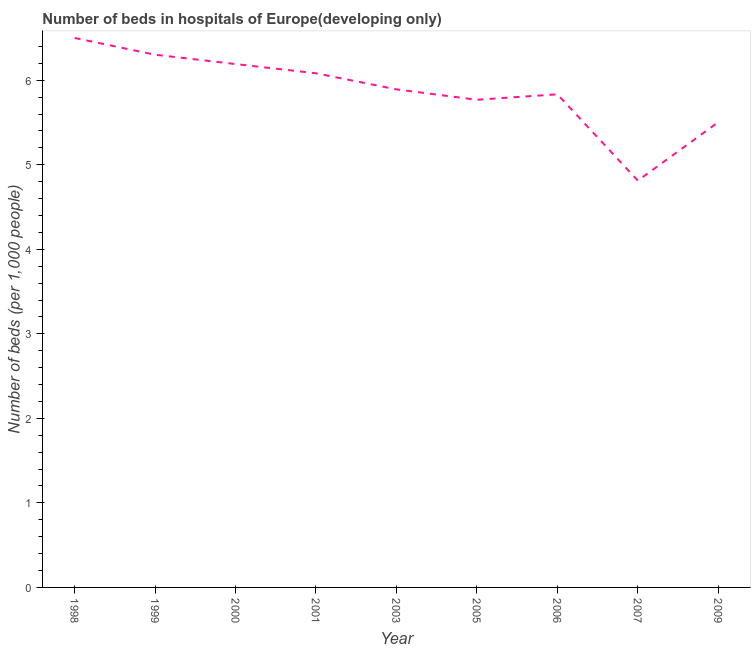What is the number of hospital beds in 1999?
Offer a very short reply. 6.3. Across all years, what is the maximum number of hospital beds?
Your answer should be compact. 6.5. Across all years, what is the minimum number of hospital beds?
Give a very brief answer. 4.81. In which year was the number of hospital beds maximum?
Keep it short and to the point. 1998. In which year was the number of hospital beds minimum?
Your answer should be compact. 2007. What is the sum of the number of hospital beds?
Your answer should be compact. 52.89. What is the difference between the number of hospital beds in 1998 and 2009?
Your response must be concise. 1. What is the average number of hospital beds per year?
Provide a succinct answer. 5.88. What is the median number of hospital beds?
Offer a very short reply. 5.89. What is the ratio of the number of hospital beds in 1998 to that in 1999?
Provide a short and direct response. 1.03. Is the difference between the number of hospital beds in 1998 and 1999 greater than the difference between any two years?
Give a very brief answer. No. What is the difference between the highest and the second highest number of hospital beds?
Provide a short and direct response. 0.2. Is the sum of the number of hospital beds in 1999 and 2000 greater than the maximum number of hospital beds across all years?
Keep it short and to the point. Yes. What is the difference between the highest and the lowest number of hospital beds?
Offer a very short reply. 1.69. In how many years, is the number of hospital beds greater than the average number of hospital beds taken over all years?
Your response must be concise. 5. How many lines are there?
Your response must be concise. 1. What is the difference between two consecutive major ticks on the Y-axis?
Provide a short and direct response. 1. Are the values on the major ticks of Y-axis written in scientific E-notation?
Offer a very short reply. No. Does the graph contain grids?
Ensure brevity in your answer.  No. What is the title of the graph?
Provide a succinct answer. Number of beds in hospitals of Europe(developing only). What is the label or title of the Y-axis?
Keep it short and to the point. Number of beds (per 1,0 people). What is the Number of beds (per 1,000 people) in 1998?
Your answer should be compact. 6.5. What is the Number of beds (per 1,000 people) in 1999?
Give a very brief answer. 6.3. What is the Number of beds (per 1,000 people) of 2000?
Provide a succinct answer. 6.19. What is the Number of beds (per 1,000 people) of 2001?
Offer a very short reply. 6.08. What is the Number of beds (per 1,000 people) in 2003?
Your answer should be compact. 5.89. What is the Number of beds (per 1,000 people) of 2005?
Your answer should be compact. 5.77. What is the Number of beds (per 1,000 people) of 2006?
Provide a succinct answer. 5.83. What is the Number of beds (per 1,000 people) of 2007?
Give a very brief answer. 4.81. What is the Number of beds (per 1,000 people) in 2009?
Make the answer very short. 5.51. What is the difference between the Number of beds (per 1,000 people) in 1998 and 1999?
Offer a terse response. 0.2. What is the difference between the Number of beds (per 1,000 people) in 1998 and 2000?
Offer a terse response. 0.31. What is the difference between the Number of beds (per 1,000 people) in 1998 and 2001?
Your answer should be very brief. 0.42. What is the difference between the Number of beds (per 1,000 people) in 1998 and 2003?
Your answer should be compact. 0.61. What is the difference between the Number of beds (per 1,000 people) in 1998 and 2005?
Offer a very short reply. 0.73. What is the difference between the Number of beds (per 1,000 people) in 1998 and 2006?
Make the answer very short. 0.67. What is the difference between the Number of beds (per 1,000 people) in 1998 and 2007?
Your answer should be very brief. 1.69. What is the difference between the Number of beds (per 1,000 people) in 1998 and 2009?
Provide a succinct answer. 1. What is the difference between the Number of beds (per 1,000 people) in 1999 and 2000?
Provide a short and direct response. 0.11. What is the difference between the Number of beds (per 1,000 people) in 1999 and 2001?
Provide a short and direct response. 0.22. What is the difference between the Number of beds (per 1,000 people) in 1999 and 2003?
Offer a terse response. 0.41. What is the difference between the Number of beds (per 1,000 people) in 1999 and 2005?
Make the answer very short. 0.53. What is the difference between the Number of beds (per 1,000 people) in 1999 and 2006?
Your answer should be compact. 0.47. What is the difference between the Number of beds (per 1,000 people) in 1999 and 2007?
Provide a succinct answer. 1.49. What is the difference between the Number of beds (per 1,000 people) in 1999 and 2009?
Your response must be concise. 0.8. What is the difference between the Number of beds (per 1,000 people) in 2000 and 2001?
Make the answer very short. 0.11. What is the difference between the Number of beds (per 1,000 people) in 2000 and 2003?
Give a very brief answer. 0.3. What is the difference between the Number of beds (per 1,000 people) in 2000 and 2005?
Your answer should be very brief. 0.42. What is the difference between the Number of beds (per 1,000 people) in 2000 and 2006?
Your response must be concise. 0.36. What is the difference between the Number of beds (per 1,000 people) in 2000 and 2007?
Offer a very short reply. 1.38. What is the difference between the Number of beds (per 1,000 people) in 2000 and 2009?
Offer a terse response. 0.69. What is the difference between the Number of beds (per 1,000 people) in 2001 and 2003?
Your answer should be compact. 0.19. What is the difference between the Number of beds (per 1,000 people) in 2001 and 2005?
Your answer should be very brief. 0.31. What is the difference between the Number of beds (per 1,000 people) in 2001 and 2006?
Provide a succinct answer. 0.25. What is the difference between the Number of beds (per 1,000 people) in 2001 and 2007?
Provide a succinct answer. 1.27. What is the difference between the Number of beds (per 1,000 people) in 2001 and 2009?
Your answer should be compact. 0.58. What is the difference between the Number of beds (per 1,000 people) in 2003 and 2005?
Your answer should be compact. 0.12. What is the difference between the Number of beds (per 1,000 people) in 2003 and 2006?
Keep it short and to the point. 0.06. What is the difference between the Number of beds (per 1,000 people) in 2003 and 2007?
Make the answer very short. 1.08. What is the difference between the Number of beds (per 1,000 people) in 2003 and 2009?
Offer a very short reply. 0.39. What is the difference between the Number of beds (per 1,000 people) in 2005 and 2006?
Offer a terse response. -0.06. What is the difference between the Number of beds (per 1,000 people) in 2005 and 2007?
Your answer should be compact. 0.96. What is the difference between the Number of beds (per 1,000 people) in 2005 and 2009?
Give a very brief answer. 0.26. What is the difference between the Number of beds (per 1,000 people) in 2006 and 2007?
Your answer should be compact. 1.02. What is the difference between the Number of beds (per 1,000 people) in 2006 and 2009?
Offer a very short reply. 0.33. What is the difference between the Number of beds (per 1,000 people) in 2007 and 2009?
Make the answer very short. -0.69. What is the ratio of the Number of beds (per 1,000 people) in 1998 to that in 1999?
Offer a very short reply. 1.03. What is the ratio of the Number of beds (per 1,000 people) in 1998 to that in 2001?
Your response must be concise. 1.07. What is the ratio of the Number of beds (per 1,000 people) in 1998 to that in 2003?
Your answer should be very brief. 1.1. What is the ratio of the Number of beds (per 1,000 people) in 1998 to that in 2005?
Your response must be concise. 1.13. What is the ratio of the Number of beds (per 1,000 people) in 1998 to that in 2006?
Provide a short and direct response. 1.11. What is the ratio of the Number of beds (per 1,000 people) in 1998 to that in 2007?
Ensure brevity in your answer.  1.35. What is the ratio of the Number of beds (per 1,000 people) in 1998 to that in 2009?
Offer a terse response. 1.18. What is the ratio of the Number of beds (per 1,000 people) in 1999 to that in 2001?
Keep it short and to the point. 1.04. What is the ratio of the Number of beds (per 1,000 people) in 1999 to that in 2003?
Your answer should be very brief. 1.07. What is the ratio of the Number of beds (per 1,000 people) in 1999 to that in 2005?
Your answer should be very brief. 1.09. What is the ratio of the Number of beds (per 1,000 people) in 1999 to that in 2007?
Your response must be concise. 1.31. What is the ratio of the Number of beds (per 1,000 people) in 1999 to that in 2009?
Provide a short and direct response. 1.15. What is the ratio of the Number of beds (per 1,000 people) in 2000 to that in 2003?
Provide a short and direct response. 1.05. What is the ratio of the Number of beds (per 1,000 people) in 2000 to that in 2005?
Offer a very short reply. 1.07. What is the ratio of the Number of beds (per 1,000 people) in 2000 to that in 2006?
Provide a short and direct response. 1.06. What is the ratio of the Number of beds (per 1,000 people) in 2000 to that in 2007?
Your answer should be very brief. 1.29. What is the ratio of the Number of beds (per 1,000 people) in 2000 to that in 2009?
Provide a short and direct response. 1.12. What is the ratio of the Number of beds (per 1,000 people) in 2001 to that in 2003?
Offer a terse response. 1.03. What is the ratio of the Number of beds (per 1,000 people) in 2001 to that in 2005?
Offer a terse response. 1.05. What is the ratio of the Number of beds (per 1,000 people) in 2001 to that in 2006?
Provide a succinct answer. 1.04. What is the ratio of the Number of beds (per 1,000 people) in 2001 to that in 2007?
Your answer should be compact. 1.26. What is the ratio of the Number of beds (per 1,000 people) in 2001 to that in 2009?
Offer a terse response. 1.1. What is the ratio of the Number of beds (per 1,000 people) in 2003 to that in 2007?
Your answer should be compact. 1.22. What is the ratio of the Number of beds (per 1,000 people) in 2003 to that in 2009?
Your response must be concise. 1.07. What is the ratio of the Number of beds (per 1,000 people) in 2005 to that in 2007?
Provide a succinct answer. 1.2. What is the ratio of the Number of beds (per 1,000 people) in 2005 to that in 2009?
Keep it short and to the point. 1.05. What is the ratio of the Number of beds (per 1,000 people) in 2006 to that in 2007?
Offer a terse response. 1.21. What is the ratio of the Number of beds (per 1,000 people) in 2006 to that in 2009?
Offer a very short reply. 1.06. What is the ratio of the Number of beds (per 1,000 people) in 2007 to that in 2009?
Your answer should be very brief. 0.87. 